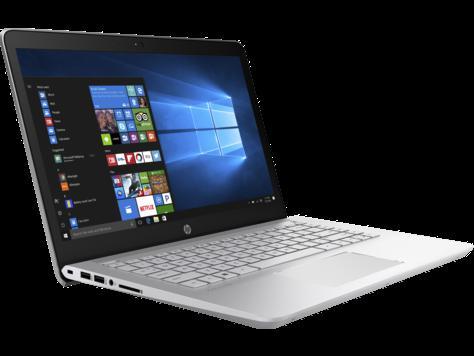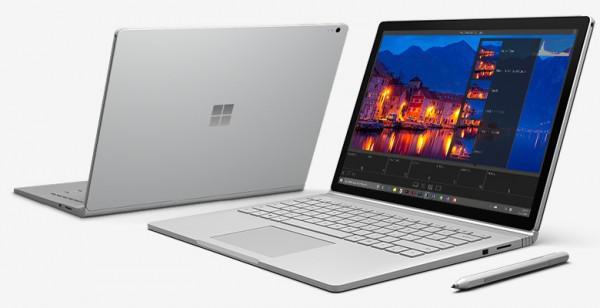The first image is the image on the left, the second image is the image on the right. Analyze the images presented: Is the assertion "There is a single laptop with a stylus pen next to it in one of the images." valid? Answer yes or no. No. The first image is the image on the left, the second image is the image on the right. Evaluate the accuracy of this statement regarding the images: "Each image includes exactly one visible screen, and the screens in the left and right images face toward each other.". Is it true? Answer yes or no. Yes. 